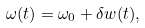<formula> <loc_0><loc_0><loc_500><loc_500>\omega ( t ) = \omega _ { 0 } + \delta w ( t ) ,</formula> 